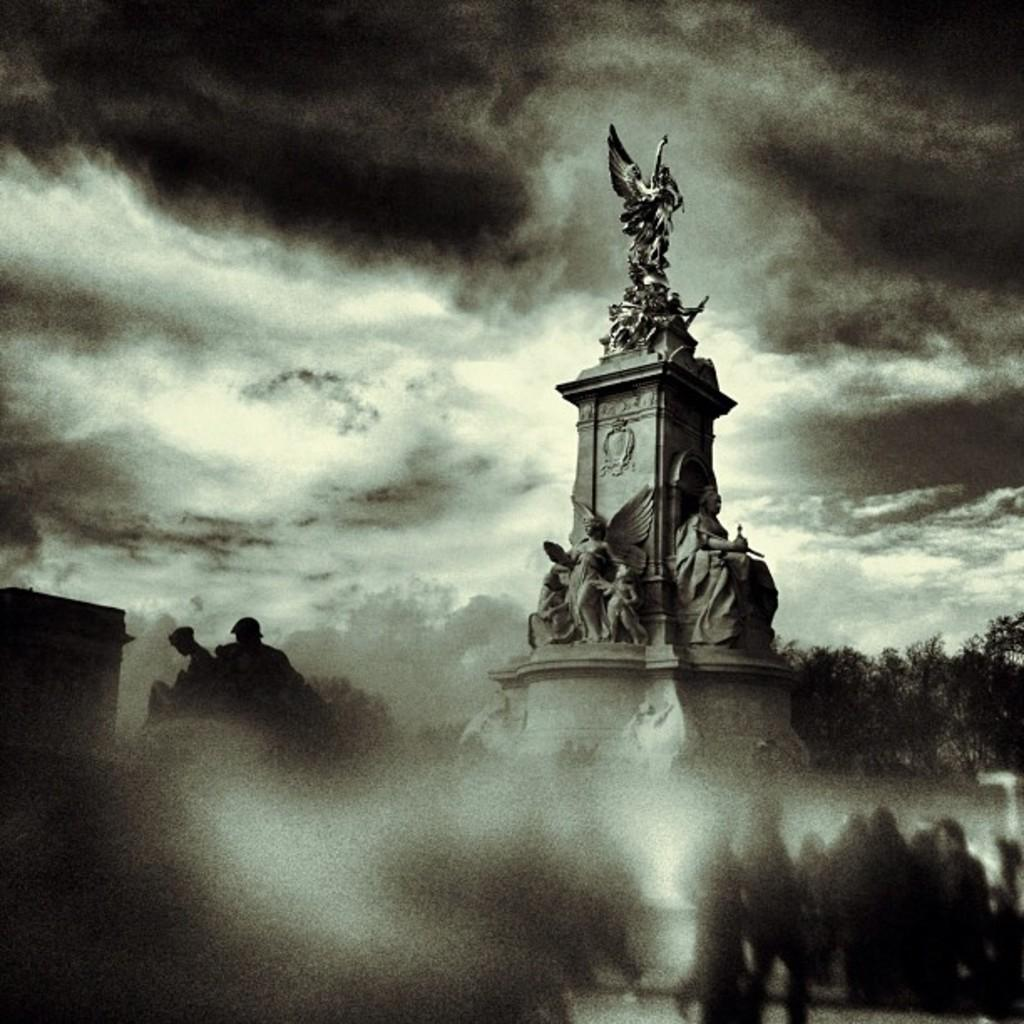What can be seen in the front of the image? There are shadows of persons in the front of the image. What is located in the center of the image? There are statues in the center of the image. What type of vegetation is visible in the background of the image? There are trees in the background of the image. How would you describe the sky in the image? The sky is cloudy in the image. How many bikes are parked next to the statues in the image? There are no bikes present in the image; it features shadows of persons, statues, trees, and a cloudy sky. Who is the owner of the statues in the image? There is no information about the ownership of the statues in the image. 